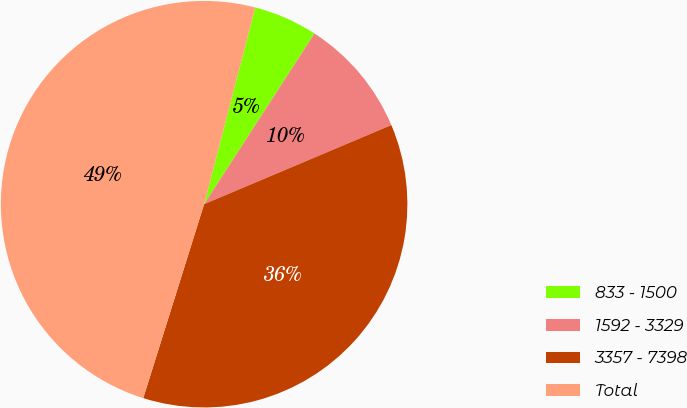Convert chart to OTSL. <chart><loc_0><loc_0><loc_500><loc_500><pie_chart><fcel>833 - 1500<fcel>1592 - 3329<fcel>3357 - 7398<fcel>Total<nl><fcel>5.09%<fcel>9.5%<fcel>36.2%<fcel>49.2%<nl></chart> 